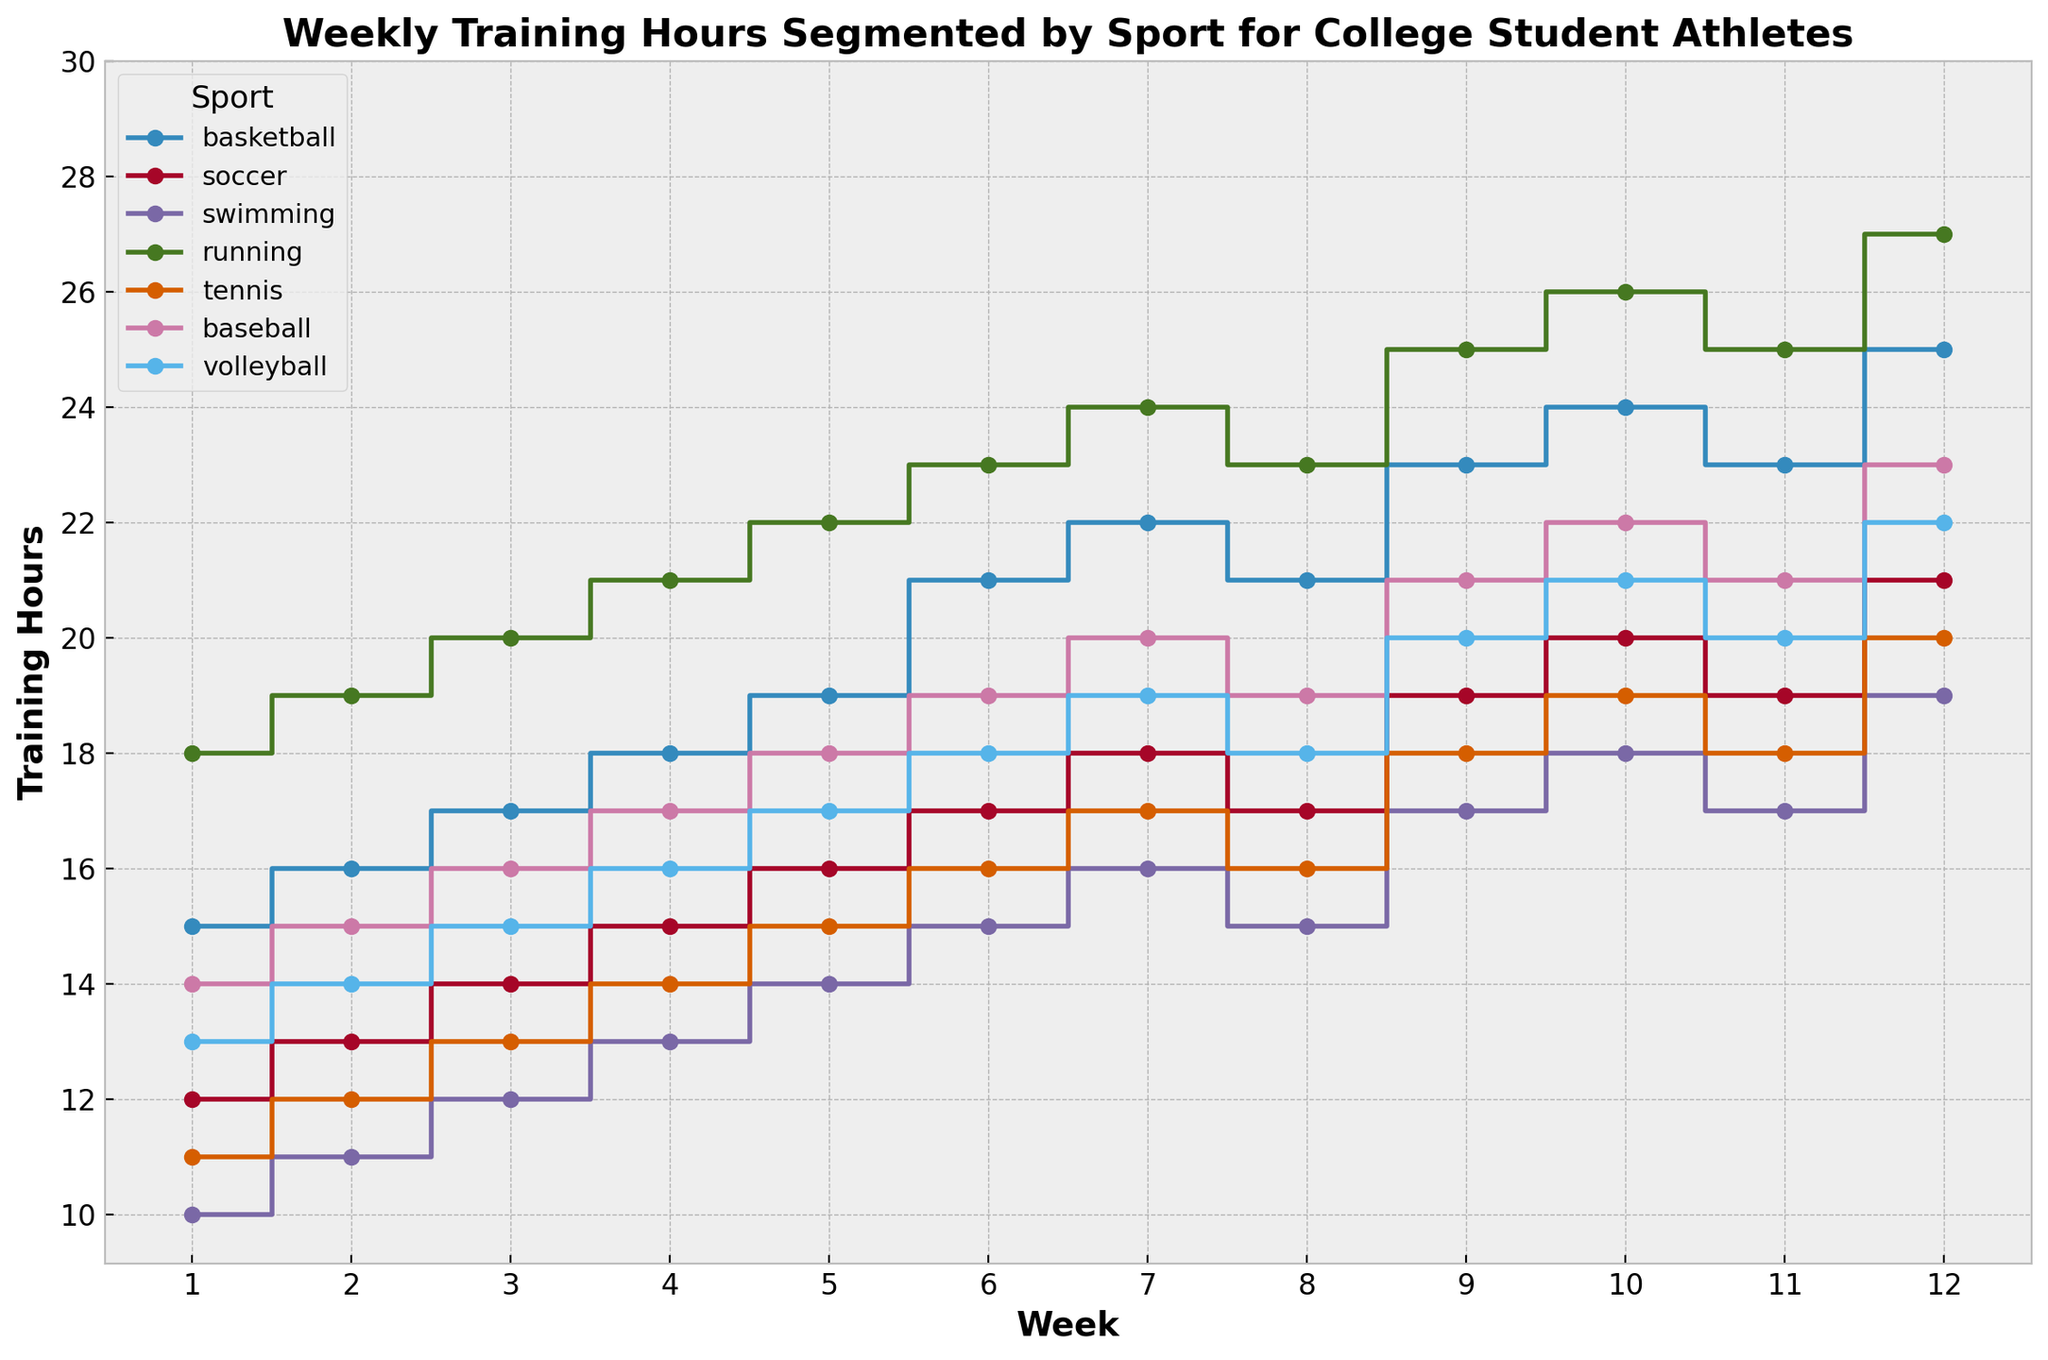What is the total increase in weekly training hours for basketball from week 1 to week 12? To calculate the total increase, subtract the week 1 hours from the week 12 hours for basketball. 25 (week 12) - 15 (week 1) = 10
Answer: 10 Which sport has seen the least progress in training hours between week 1 and week 12? For each sport, subtract the week 1 training hours from the week 12 training hours and find the smallest result. Swimming: 19 - 10 = 9, Soccer: 21 - 12 = 9, Tennis: 20 - 11 = 9, Volleyball: 22 - 13 = 9, Basketball: 25 - 15 = 10, Baseball: 23 - 14 = 9, Running: 27 - 18 = 9. Hence, Swimming, Soccer, Tennis, Volleyball, Baseball saw the least progress with 9 hours increase.
Answer: Swimming, Soccer, Tennis, Volleyball, Baseball Between weeks 6 and 8, which sport shows the most significant drop in training hours? Compare the training hours from week 6 and week 8 for each sport and find the greatest decrease. Basketball: 22 - 21 = 1, Soccer: 18 - 17 = 1, Swimming: 16 - 15 = 1, Running: 24 - 23 = 1, Tennis: 17 - 16 = 1, Baseball: 20 - 19 = 1, Volleyball: 19 - 18 = 1. All sports show a decrease of only 1 hour.
Answer: All sports (1 hour drop each) Which sport consistently gains training hours weekly without any drops? Inspect each sport’s training hours week by week to ensure there are no decreases in any week. Soccer and Running consistently increase every week.
Answer: Soccer, Running On average, how many training hours per week do tennis players train? Sum the weekly training hours for Tennis and divide by the number of weeks. (11 + 12 + 13 + 14 + 15 + 16 + 17 + 16 + 18 + 19 + 18 + 20) / 12 = 16
Answer: 16 Which sport has the highest training hours in week 10? Compare the training hours across sports in week 10. Basketball: 24, Soccer: 20, Swimming: 18, Running: 26, Tennis: 19, Baseball: 22, Volleyball: 21. Running has the highest with 26 hours.
Answer: Running During which weeks does volleyball have the same training hours as baseball? Check each week where both sports have the same hours. In week 11, both Volleyball and Baseball have 21 hours.
Answer: Week 11 What's the difference in the number of training hours between soccer and baseball in week 5? Subtract the training hours of soccer from baseball in week 5. 18 (baseball) - 16 (soccer) = 2
Answer: 2 